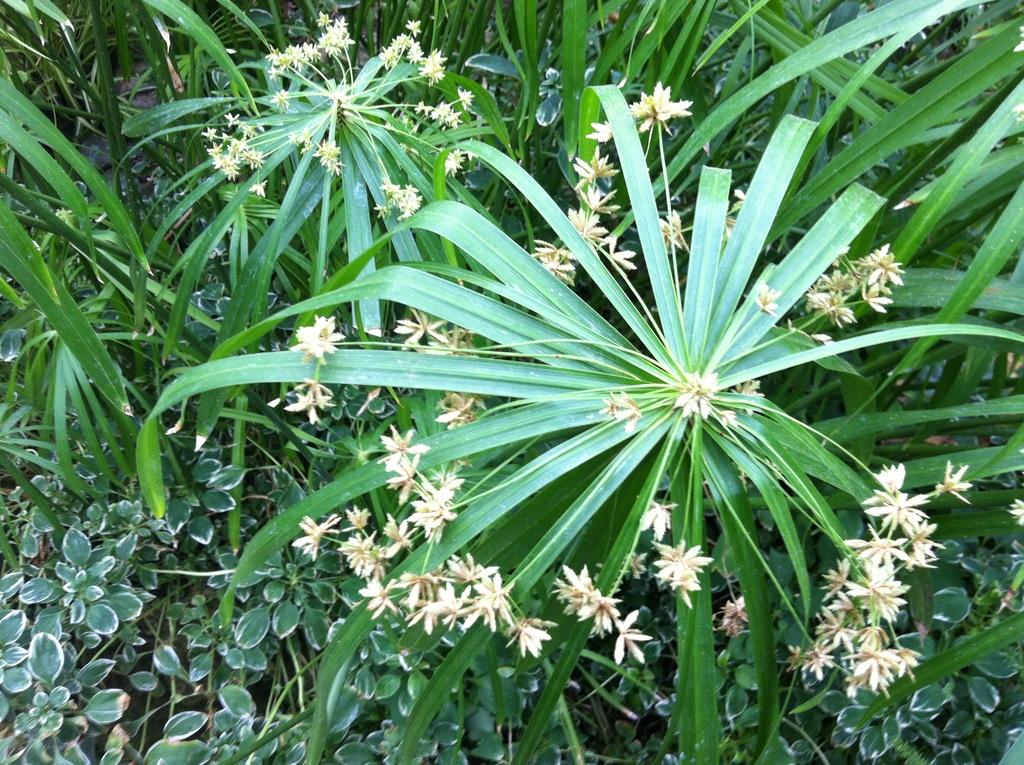What type of living organisms can be seen in the image? Plants, flowers, and leaves are visible in the image. Can you describe the specific parts of the plants that are present? Yes, there are flowers and leaves in the image. What type of meal is being prepared using the cabbage in the image? There is no cabbage present in the image, and therefore no meal preparation can be observed. Can you tell me how many dinosaurs are visible in the image? There are no dinosaurs present in the image. 